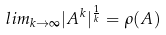Convert formula to latex. <formula><loc_0><loc_0><loc_500><loc_500>l i m _ { k \rightarrow \infty } | A ^ { k } | ^ { \frac { 1 } { k } } = \rho ( A )</formula> 